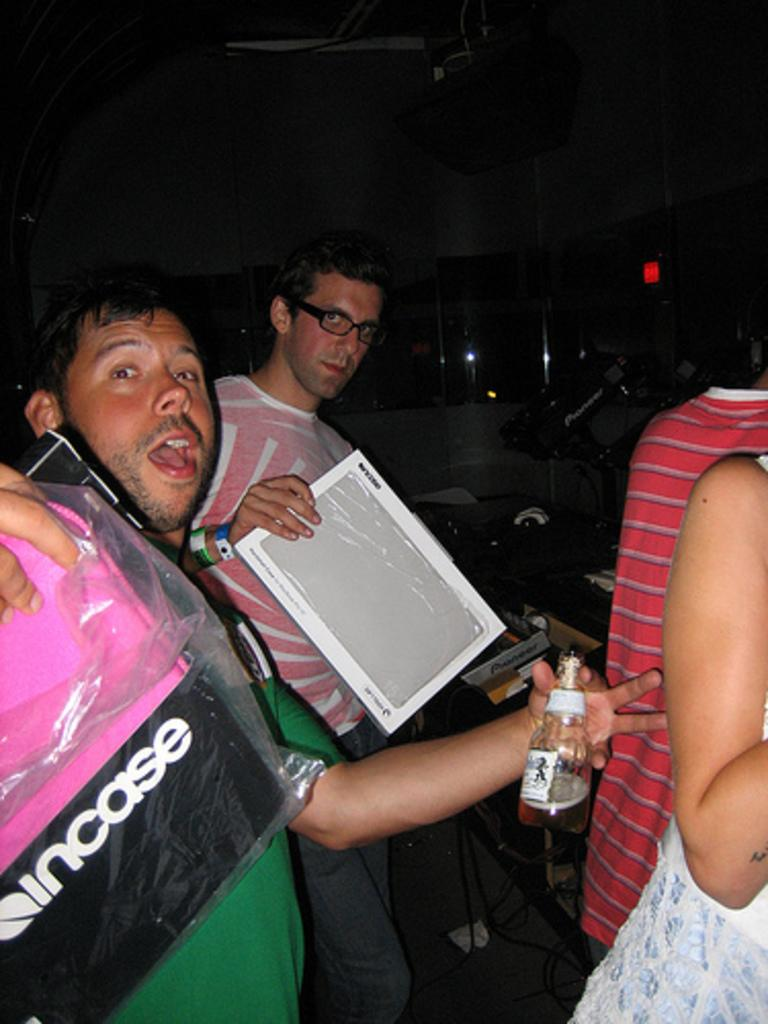What is happening in the foreground of the image? There are people in the foreground of the image. What are the people holding in their hands? The people are holding objects in their hands. Can you describe the background of the image? There is other equipment visible in the background of the image. How many brothers can be seen in the image? There is no mention of brothers in the image, so we cannot determine the number of brothers present. 